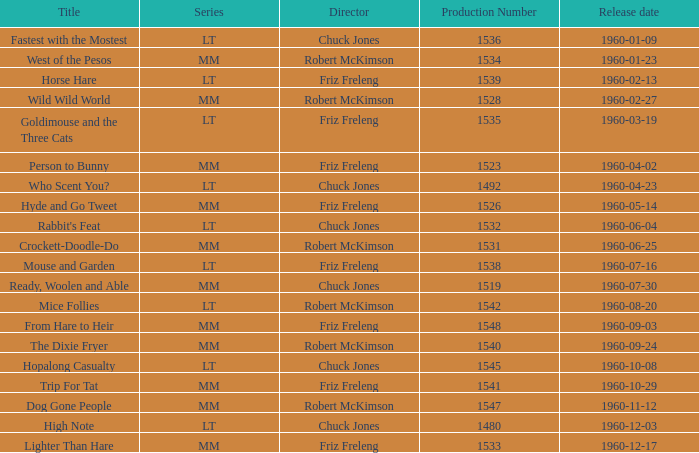What is the production number of From Hare to Heir? 1548.0. 